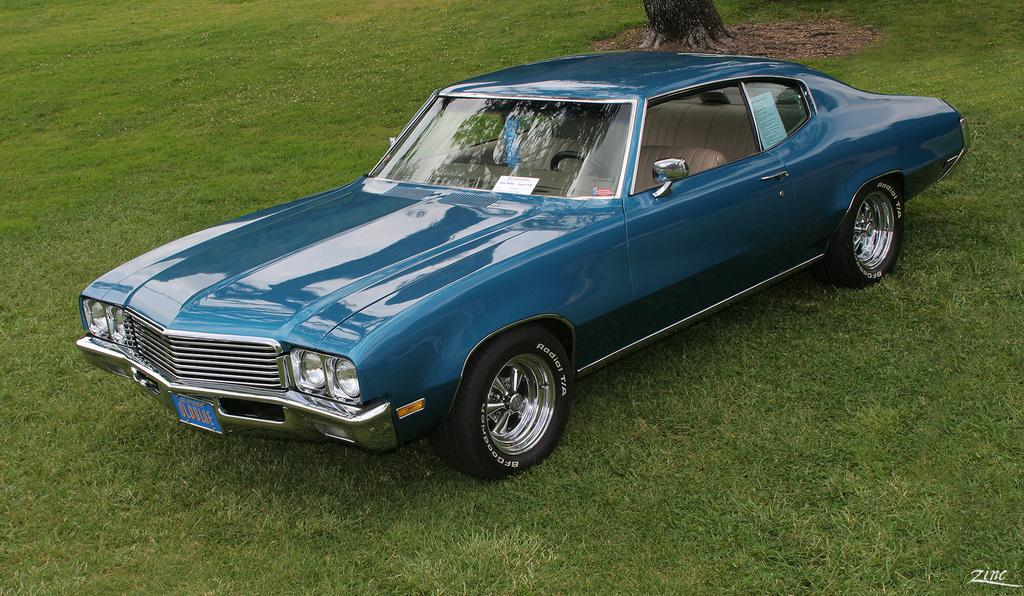What is the main subject of the image? The main subject of the image is a car. What natural element is present in the image? There is a trunk of a tree in the image. What type of ground cover can be seen in the image? There is grass visible in the image. Is there any text present in the image? Yes, there is text on the image. How many books are stacked on the car in the image? There are no books present in the image; it only features a car, a tree trunk, grass, and text. 